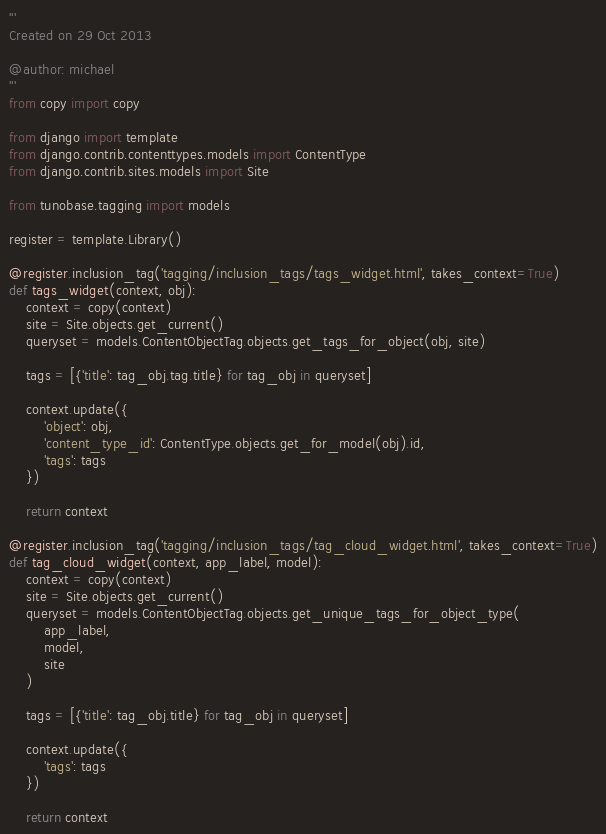Convert code to text. <code><loc_0><loc_0><loc_500><loc_500><_Python_>'''
Created on 29 Oct 2013

@author: michael
'''
from copy import copy

from django import template
from django.contrib.contenttypes.models import ContentType
from django.contrib.sites.models import Site

from tunobase.tagging import models

register = template.Library()

@register.inclusion_tag('tagging/inclusion_tags/tags_widget.html', takes_context=True)
def tags_widget(context, obj):
    context = copy(context)
    site = Site.objects.get_current()
    queryset = models.ContentObjectTag.objects.get_tags_for_object(obj, site)
    
    tags = [{'title': tag_obj.tag.title} for tag_obj in queryset]
        
    context.update({
        'object': obj,
        'content_type_id': ContentType.objects.get_for_model(obj).id,
        'tags': tags
    })
    
    return context

@register.inclusion_tag('tagging/inclusion_tags/tag_cloud_widget.html', takes_context=True)
def tag_cloud_widget(context, app_label, model):
    context = copy(context)
    site = Site.objects.get_current()
    queryset = models.ContentObjectTag.objects.get_unique_tags_for_object_type(
        app_label, 
        model, 
        site
    )
    
    tags = [{'title': tag_obj.title} for tag_obj in queryset]
        
    context.update({
        'tags': tags
    })
    
    return context</code> 